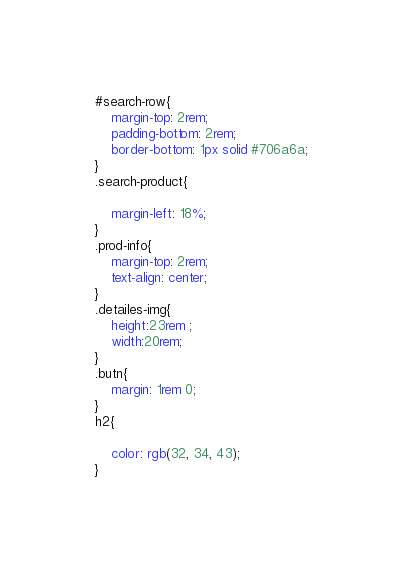<code> <loc_0><loc_0><loc_500><loc_500><_CSS_>#search-row{
    margin-top: 2rem;
    padding-bottom: 2rem;
    border-bottom: 1px solid #706a6a;
}
.search-product{
    
    margin-left: 18%;
}
.prod-info{
    margin-top: 2rem;
    text-align: center;
}
.detailes-img{
    height:23rem ;
    width:20rem;
}
.butn{
    margin: 1rem 0;
}
h2{
    
    color: rgb(32, 34, 43);
}



</code> 